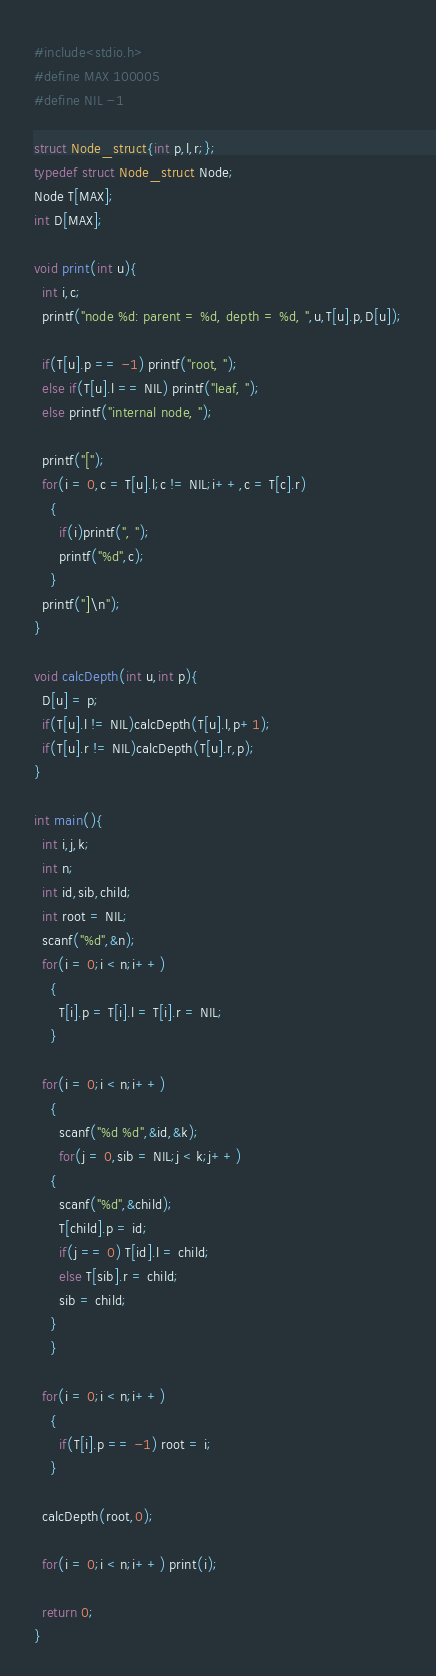<code> <loc_0><loc_0><loc_500><loc_500><_C_>#include<stdio.h>
#define MAX 100005
#define NIL -1

struct Node_struct{int p,l,r;};
typedef struct Node_struct Node;
Node T[MAX];
int D[MAX];

void print(int u){
  int i,c;
  printf("node %d: parent = %d, depth = %d, ",u,T[u].p,D[u]);

  if(T[u].p == -1) printf("root, ");
  else if(T[u].l == NIL) printf("leaf, ");
  else printf("internal node, ");

  printf("[");
  for(i = 0,c = T[u].l;c != NIL;i++,c = T[c].r)
    {
      if(i)printf(", ");
      printf("%d",c);
    }
  printf("]\n");
}

void calcDepth(int u,int p){
  D[u] = p;
  if(T[u].l != NIL)calcDepth(T[u].l,p+1);
  if(T[u].r != NIL)calcDepth(T[u].r,p);
}

int main(){
  int i,j,k;
  int n;
  int id,sib,child;
  int root = NIL;
  scanf("%d",&n);
  for(i = 0;i < n;i++)
    {
      T[i].p = T[i].l = T[i].r = NIL;
    }

  for(i = 0;i < n;i++)
    {
      scanf("%d %d",&id,&k);
      for(j = 0,sib = NIL;j < k;j++)
	{
	  scanf("%d",&child);
	  T[child].p = id;
	  if(j == 0) T[id].l = child;
	  else T[sib].r = child;
	  sib = child;
	}
    }

  for(i = 0;i < n;i++)
    {
      if(T[i].p == -1) root = i;
    }

  calcDepth(root,0);

  for(i = 0;i < n;i++) print(i);

  return 0;
}

</code> 